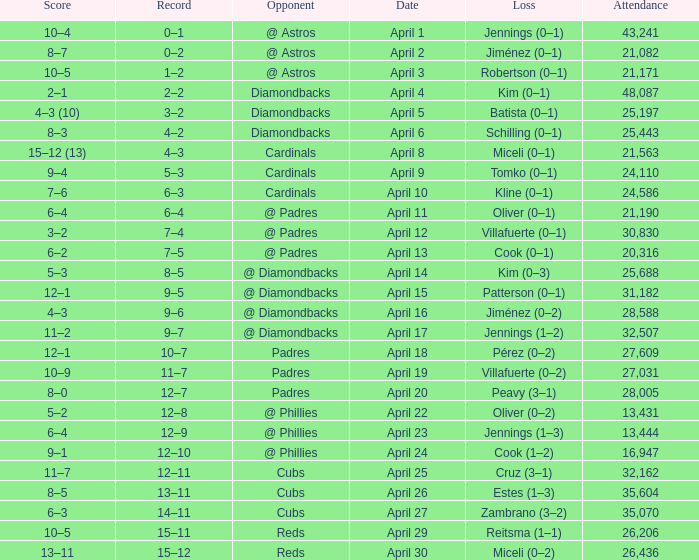Who is the opponent on april 16? @ Diamondbacks. 